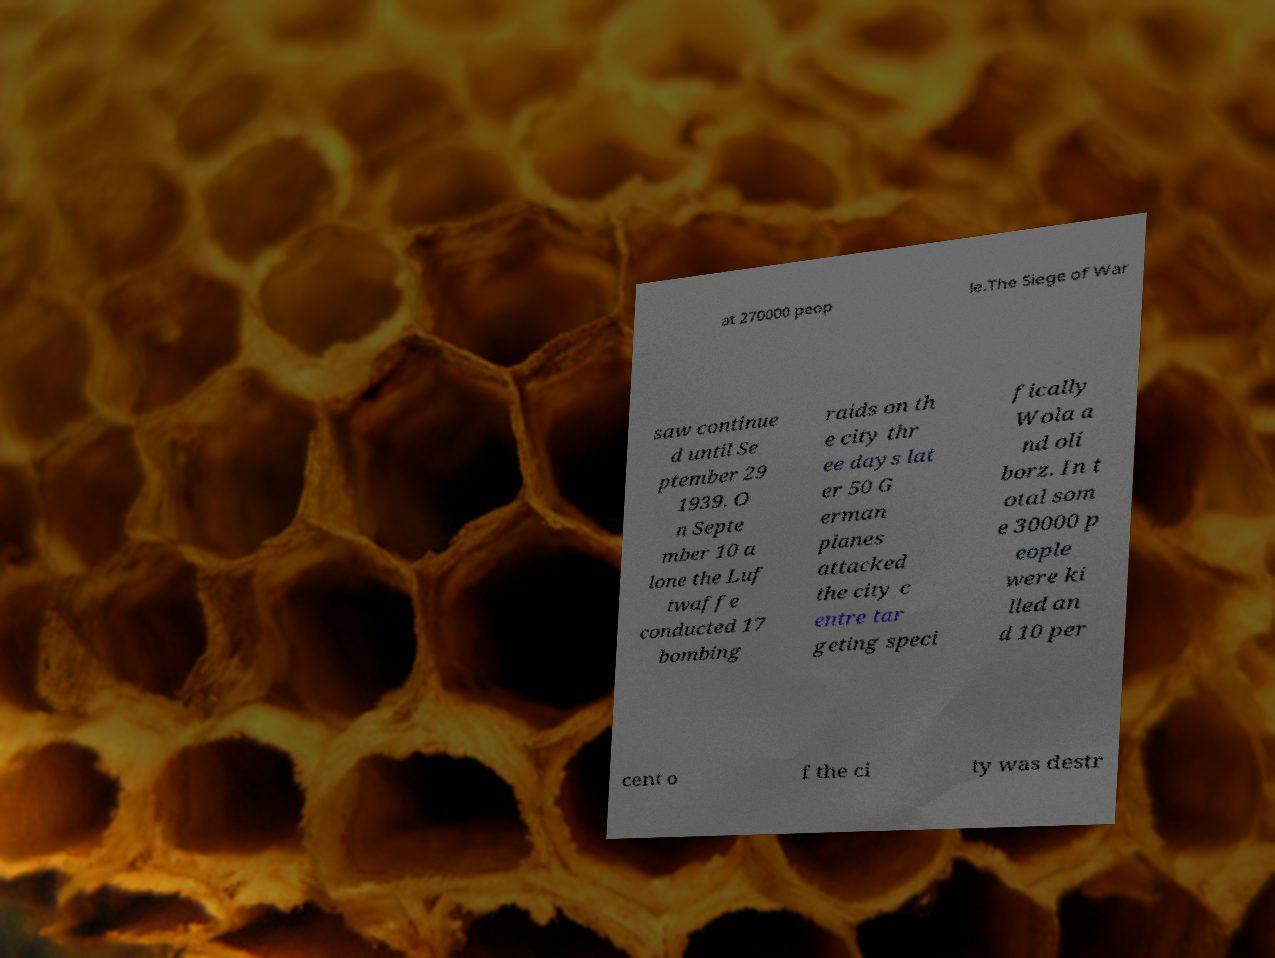There's text embedded in this image that I need extracted. Can you transcribe it verbatim? at 270000 peop le.The Siege of War saw continue d until Se ptember 29 1939. O n Septe mber 10 a lone the Luf twaffe conducted 17 bombing raids on th e city thr ee days lat er 50 G erman planes attacked the city c entre tar geting speci fically Wola a nd oli borz. In t otal som e 30000 p eople were ki lled an d 10 per cent o f the ci ty was destr 